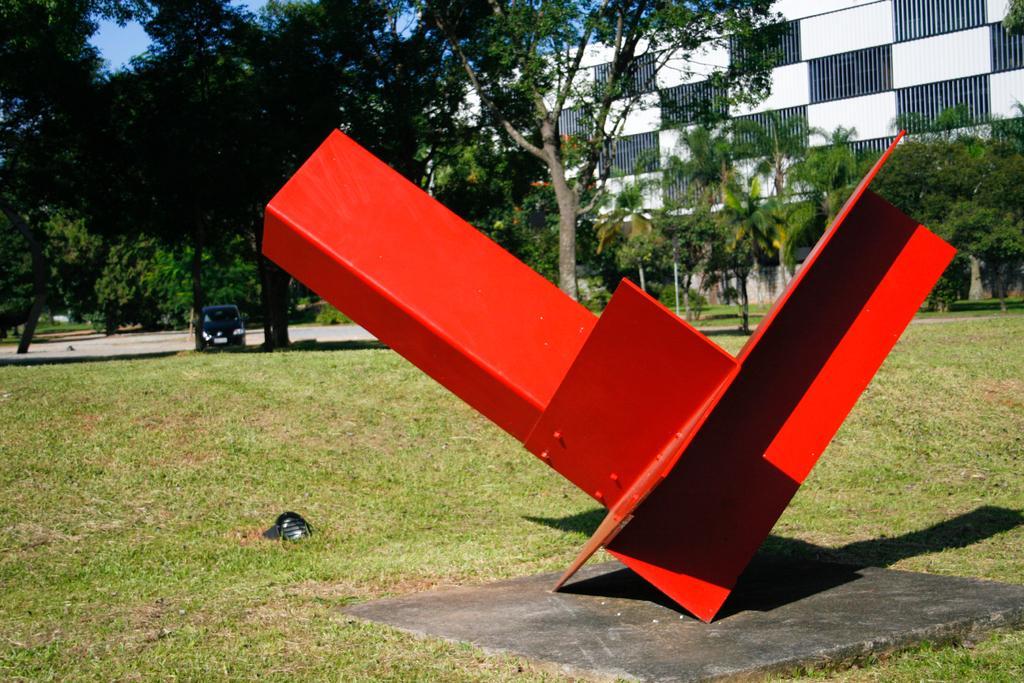In one or two sentences, can you explain what this image depicts? In this image I can see a red color object. Background I can see trees in green color and sky in blue color, and I can also see a vehicle on the road. 